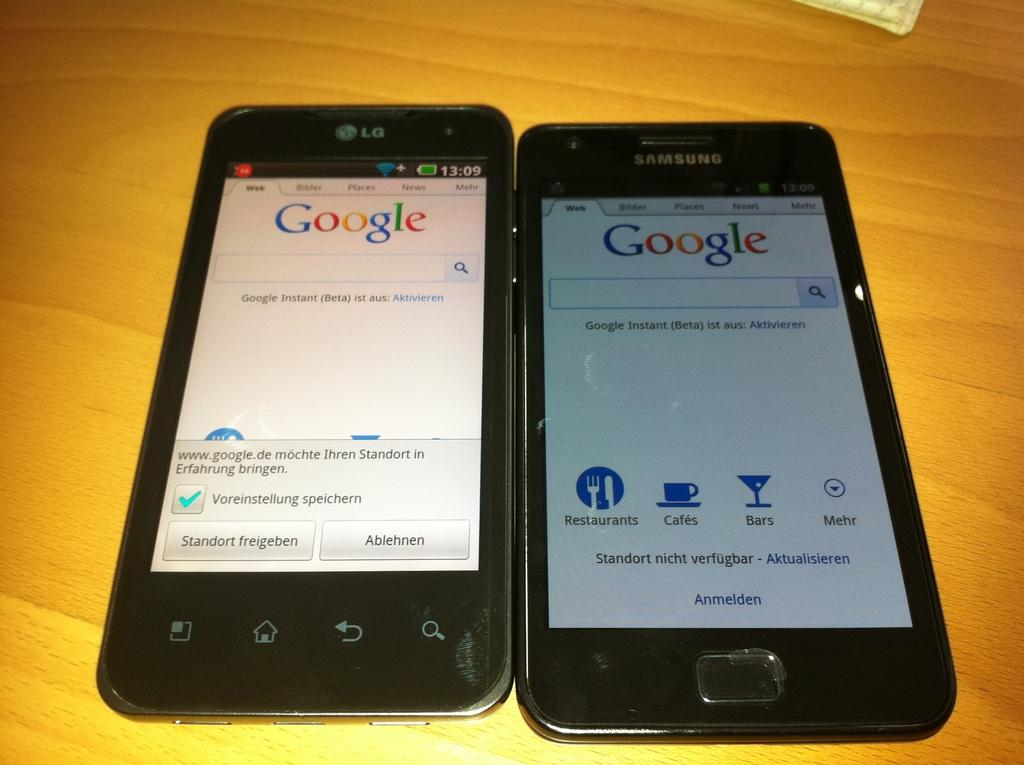<image>
Describe the image concisely. A black LG smartphone side by side a Samsung black smartphone on a wood table 